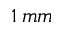<formula> <loc_0><loc_0><loc_500><loc_500>1 \, m m</formula> 